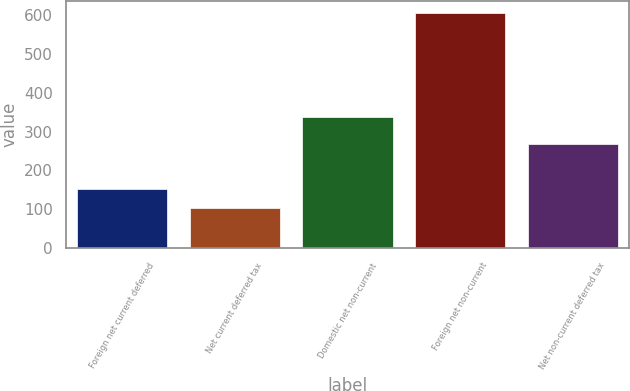Convert chart to OTSL. <chart><loc_0><loc_0><loc_500><loc_500><bar_chart><fcel>Foreign net current deferred<fcel>Net current deferred tax<fcel>Domestic net non-current<fcel>Foreign net non-current<fcel>Net non-current deferred tax<nl><fcel>152.97<fcel>102.7<fcel>336.9<fcel>605.4<fcel>268.5<nl></chart> 